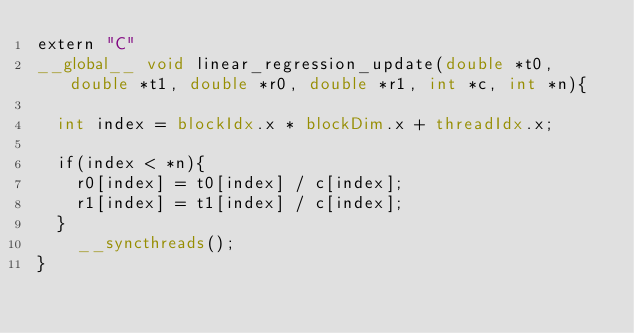<code> <loc_0><loc_0><loc_500><loc_500><_Cuda_>extern "C"
__global__ void linear_regression_update(double *t0, double *t1, double *r0, double *r1, int *c, int *n){
	
	int index = blockIdx.x * blockDim.x + threadIdx.x;

	if(index < *n){
		r0[index] = t0[index] / c[index];
		r1[index] = t1[index] / c[index];
	}
  	__syncthreads();
}
</code> 